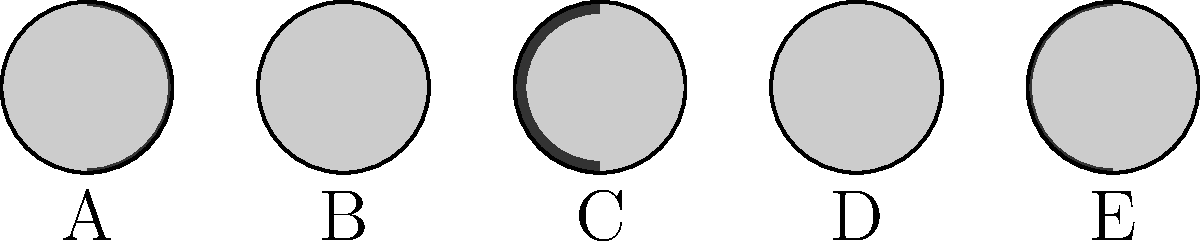As a Canadian musician inspired by Levi Brenton Williams' cosmic themes, you're composing a song about lunar cycles. Which of the moon phases shown above (A, B, C, D, or E) represents the First Quarter phase? To determine which diagram represents the First Quarter phase, let's go through the phases step-by-step:

1. The lunar cycle begins with the New Moon (not shown), where the Moon is completely dark.

2. As the cycle progresses, we see a Waxing Crescent (similar to diagram A).

3. The First Quarter phase occurs when exactly half of the Moon's visible surface is illuminated on the right side, as seen from Earth.

4. After the First Quarter, we see a Waxing Gibbous phase (similar to diagram D).

5. The cycle reaches Full Moon when the entire visible surface is illuminated (similar to diagram E, but fully lit).

6. The cycle then continues with Waning Gibbous, Last Quarter, and Waning Crescent before returning to New Moon.

Looking at the diagrams:
A: Waxing Crescent (small portion illuminated on the right)
B: Approaching First Quarter (almost half illuminated on the right)
C: First Quarter (exactly half illuminated on the right)
D: Waxing Gibbous (more than half, but not fully illuminated)
E: Approaching Full Moon (almost fully illuminated)

Therefore, diagram C represents the First Quarter phase.
Answer: C 